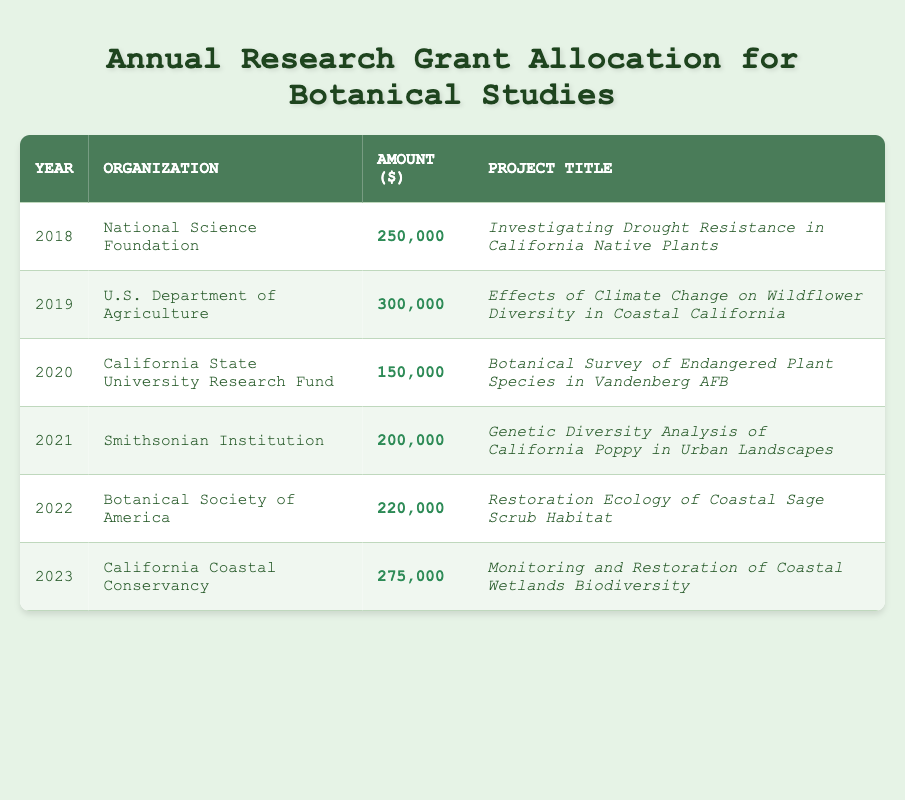What was the highest grant amount allocated, and in which year was it awarded? Reviewing the table, the highest grant amount is 300,000, which was awarded in 2019 by the U.S. Department of Agriculture.
Answer: 300,000 in 2019 How much funding was allocated for the project in 2020? From the table, the amount allocated for the project "Botanical Survey of Endangered Plant Species in Vandenberg AFB" in 2020 was 150,000.
Answer: 150,000 What is the total amount of funding allocated from 2018 to 2022? To find the total, add the grant amounts for those years: 250,000 + 300,000 + 150,000 + 200,000 + 220,000 = 1,120,000.
Answer: 1,120,000 Did the National Science Foundation fund any projects in 2022? The table shows the National Science Foundation did not fund projects in 2022; that year's funding was allocated to the Botanical Society of America.
Answer: No How does the grant amount for the project in 2021 compare to the one in 2023? The project in 2021 received 200,000, and the project in 2023 received 275,000. Since 275,000 is greater than 200,000, the 2023 project received more funding than the 2021 project.
Answer: 2023 project had more funding What is the average grant amount from 2018 to 2023? First, add the total amounts from each year: 250,000 + 300,000 + 150,000 + 200,000 + 220,000 + 275,000 = 1,395,000. Then divide by the number of years (6): 1,395,000 / 6 = 232,500.
Answer: 232,500 Which organization funded the project focused on restoring coastal sage scrub habitat? The table indicates that the Botanical Society of America funded the project titled "Restoration Ecology of Coastal Sage Scrub Habitat" in 2022.
Answer: Botanical Society of America Was there a project specifically focused on endangered plant species at Vandenberg AFB? Yes, the project titled "Botanical Survey of Endangered Plant Species in Vandenberg AFB" was funded in 2020.
Answer: Yes What was the trend in grant amounts from 2018 to 2023? Analyzing the amounts: 250,000 (2018), 300,000 (2019), 150,000 (2020), 200,000 (2021), 220,000 (2022), and 275,000 (2023), the trend shows an initial increase to 2019, followed by a decrease in 2020, then a fluctuating amount with an overall increase from 2020 to 2023.
Answer: Fluctuating trend with overall increase from 2020 to 2023 